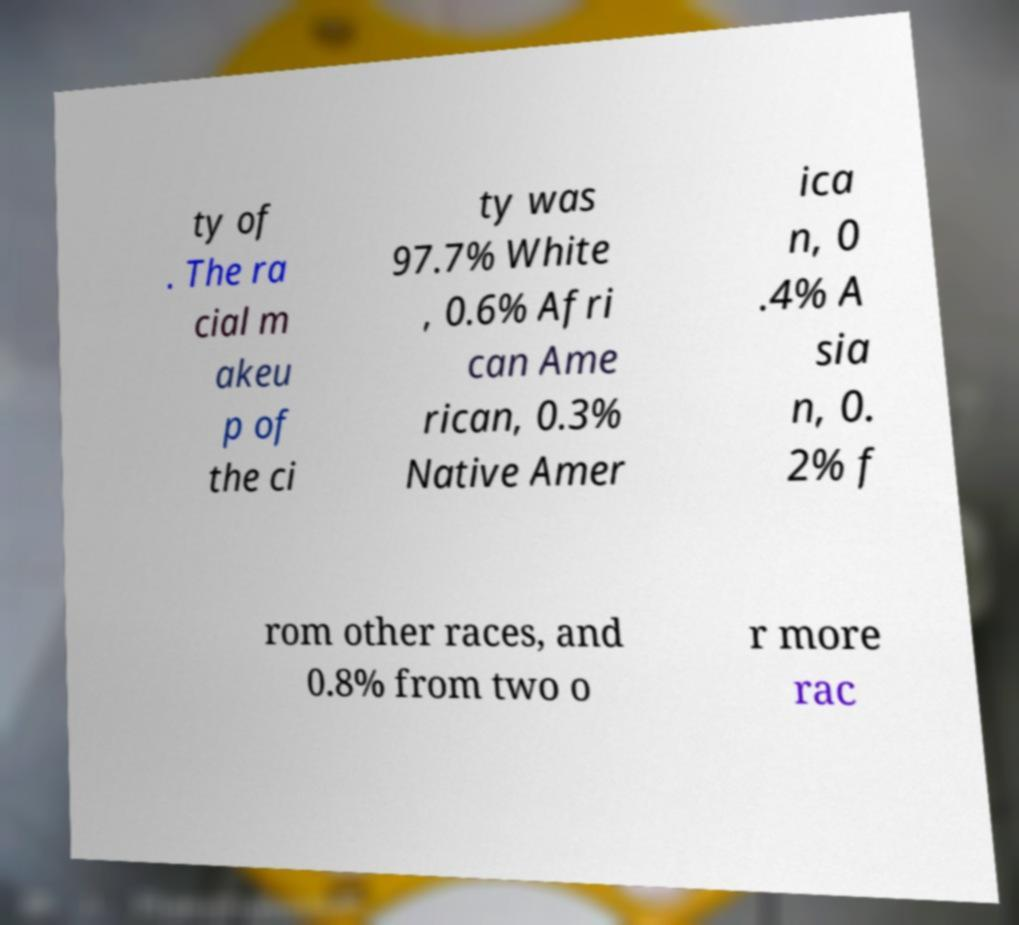What messages or text are displayed in this image? I need them in a readable, typed format. ty of . The ra cial m akeu p of the ci ty was 97.7% White , 0.6% Afri can Ame rican, 0.3% Native Amer ica n, 0 .4% A sia n, 0. 2% f rom other races, and 0.8% from two o r more rac 